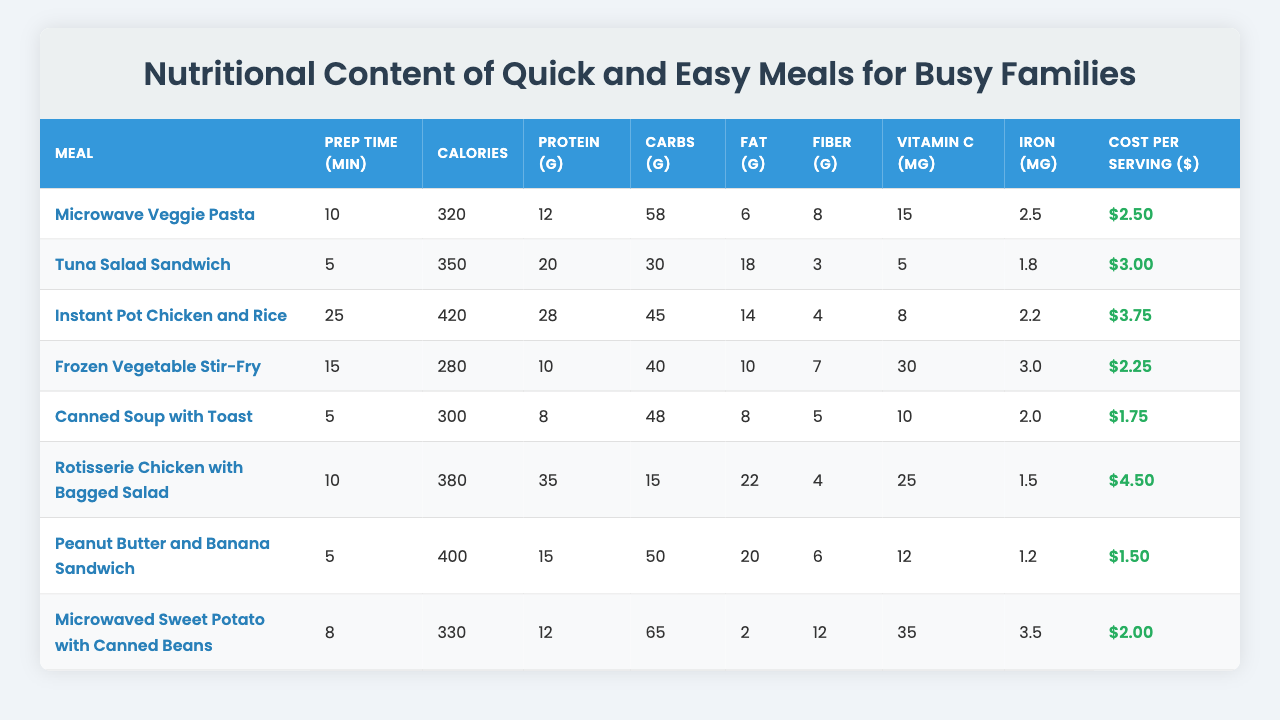What meal has the highest protein content? By looking at the protein grams in the table, "Rotisserie Chicken with Bagged Salad" has 35 grams of protein, which is the highest compared to other meals.
Answer: Rotisserie Chicken with Bagged Salad Which meal has the lowest cost per serving? The costs per serving are compared, and "Peanut Butter and Banana Sandwich" has the lowest cost at $1.50.
Answer: Peanut Butter and Banana Sandwich What is the total calorie content of the two meals with the highest calories? The two meals with the highest calories are "Instant Pot Chicken and Rice" with 420 calories, and "Rotisserie Chicken with Bagged Salad" with 380 calories. Adding these gives 420 + 380 = 800 calories.
Answer: 800 calories Which meal takes the longest to prepare? Among the prep times listed, "Instant Pot Chicken and Rice" has the longest prep time of 25 minutes.
Answer: Instant Pot Chicken and Rice Is it true that all meals have at least 10 grams of fiber? By checking the fiber grams in each meal, "Tuna Salad Sandwich" has 3 grams and "Canned Soup with Toast" has 5 grams, which are both below 10 grams, making the statement false.
Answer: False What is the average vitamin C content of the meals? The vitamin C contents are 15, 5, 8, 30, 10, 25, 12, and 35 mg. Summing these gives 105 mg. There are 8 meals, so the average is 105/8 = 13.125 mg.
Answer: 13.125 mg Which meal offers the most Vitamin C for the cost? To find the meal that offers the most Vitamin C per dollar, we calculate the Vitamin C per cost for each meal. "Microwaved Sweet Potato with Canned Beans" provides 35 mg for $2.00, giving 17.5 mg per dollar, which is the highest.
Answer: Microwaved Sweet Potato with Canned Beans How much more fat does the "Tuna Salad Sandwich" have compared to "Frozen Vegetable Stir-Fry"? The "Tuna Salad Sandwich" has 18 grams of fat, and the "Frozen Vegetable Stir-Fry" has 10 grams. The difference is 18 - 10 = 8 grams.
Answer: 8 grams What is the total amount of carbohydrates in the meals that take less than 10 minutes to prepare? The meals that take less than 10 minutes are "Tuna Salad Sandwich" (30 grams), "Microwave Veggie Pasta" (58 grams), "Canned Soup with Toast" (48 grams), and "Peanut Butter and Banana Sandwich" (50 grams). The total is 30 + 58 + 48 + 50 = 186 grams.
Answer: 186 grams Do most of the meals have more calories than the average calorie content of the meals? The average calorie count is calculated as (320 + 350 + 420 + 280 + 300 + 380 + 400 + 330) / 8 = 351.25. Comparing all meal calories shows 4 meals are above the average (Instant Pot Chicken and Rice, Rotisserie Chicken with Bagged Salad, Tuna Salad Sandwich, and Peanut Butter and Banana Sandwich).
Answer: Yes 